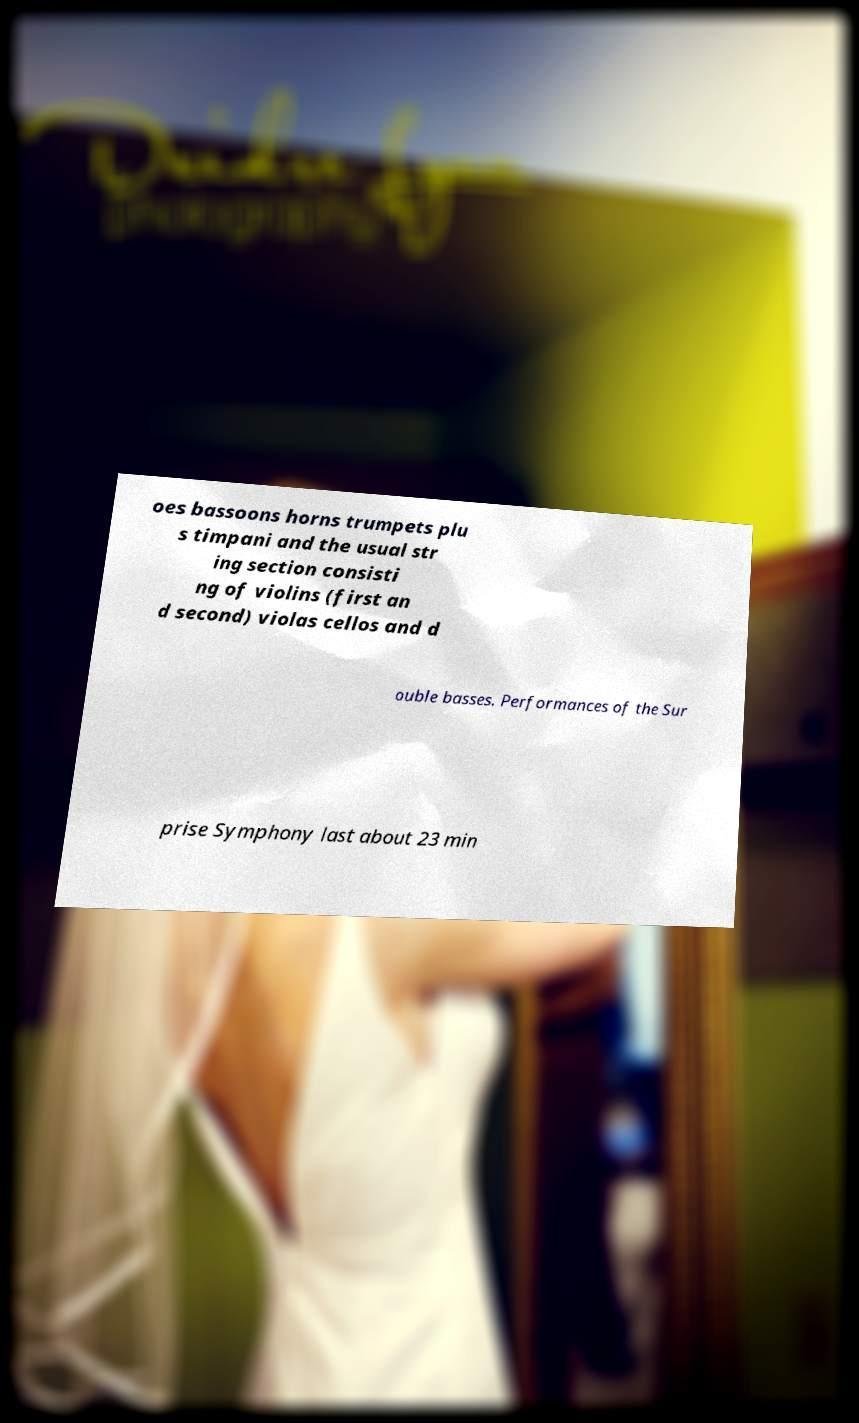Please identify and transcribe the text found in this image. oes bassoons horns trumpets plu s timpani and the usual str ing section consisti ng of violins (first an d second) violas cellos and d ouble basses. Performances of the Sur prise Symphony last about 23 min 